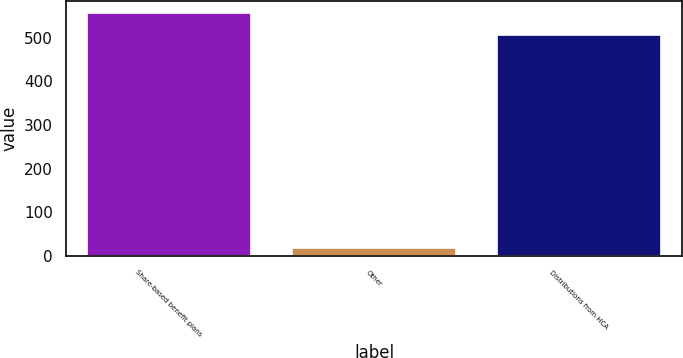<chart> <loc_0><loc_0><loc_500><loc_500><bar_chart><fcel>Share-based benefit plans<fcel>Other<fcel>Distributions from HCA<nl><fcel>555.5<fcel>18<fcel>505<nl></chart> 